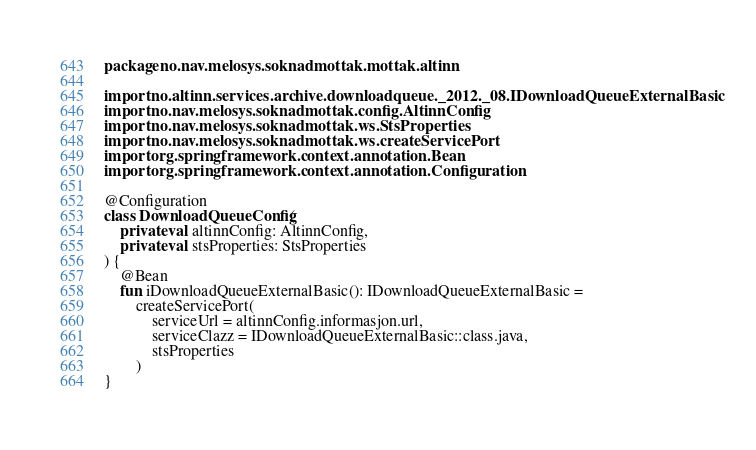Convert code to text. <code><loc_0><loc_0><loc_500><loc_500><_Kotlin_>package no.nav.melosys.soknadmottak.mottak.altinn

import no.altinn.services.archive.downloadqueue._2012._08.IDownloadQueueExternalBasic
import no.nav.melosys.soknadmottak.config.AltinnConfig
import no.nav.melosys.soknadmottak.ws.StsProperties
import no.nav.melosys.soknadmottak.ws.createServicePort
import org.springframework.context.annotation.Bean
import org.springframework.context.annotation.Configuration

@Configuration
class DownloadQueueConfig(
    private val altinnConfig: AltinnConfig,
    private val stsProperties: StsProperties
) {
    @Bean
    fun iDownloadQueueExternalBasic(): IDownloadQueueExternalBasic =
        createServicePort(
            serviceUrl = altinnConfig.informasjon.url,
            serviceClazz = IDownloadQueueExternalBasic::class.java,
            stsProperties
        )
}
</code> 